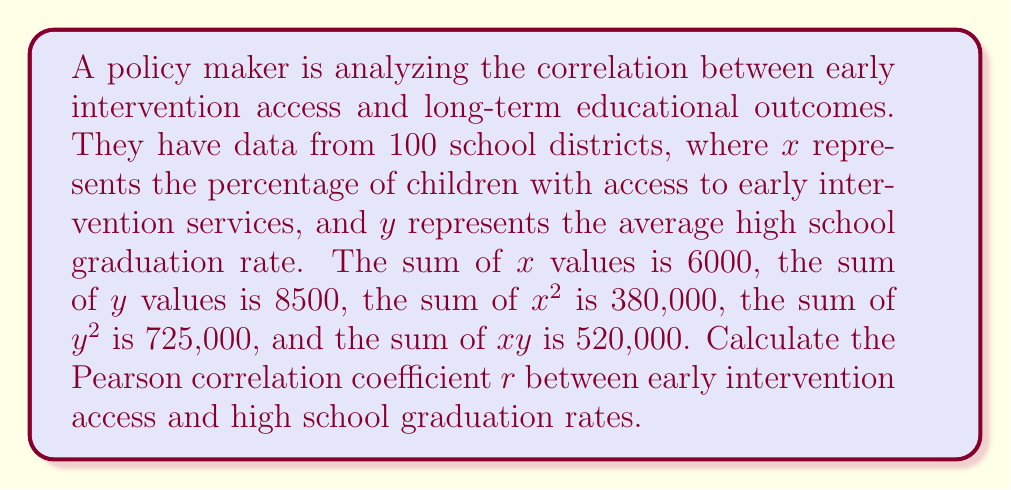What is the answer to this math problem? To calculate the Pearson correlation coefficient, we'll use the formula:

$$r = \frac{n\sum xy - \sum x \sum y}{\sqrt{[n\sum x^2 - (\sum x)^2][n\sum y^2 - (\sum y)^2]}}$$

Where:
$n$ = number of data points (100)
$\sum x$ = sum of x values (6000)
$\sum y$ = sum of y values (8500)
$\sum x^2$ = sum of squared x values (380,000)
$\sum y^2$ = sum of squared y values (725,000)
$\sum xy$ = sum of products of x and y (520,000)

Step 1: Calculate the numerator
$$n\sum xy - \sum x \sum y = (100 \times 520,000) - (6000 \times 8500) = 52,000,000 - 51,000,000 = 1,000,000$$

Step 2: Calculate the first part of the denominator
$$n\sum x^2 - (\sum x)^2 = (100 \times 380,000) - 6000^2 = 38,000,000 - 36,000,000 = 2,000,000$$

Step 3: Calculate the second part of the denominator
$$n\sum y^2 - (\sum y)^2 = (100 \times 725,000) - 8500^2 = 72,500,000 - 72,250,000 = 250,000$$

Step 4: Multiply the results from steps 2 and 3
$$2,000,000 \times 250,000 = 500,000,000,000$$

Step 5: Take the square root of the result from step 4
$$\sqrt{500,000,000,000} = 707,106.7812$$

Step 6: Divide the numerator by the denominator
$$r = \frac{1,000,000}{707,106.7812} \approx 0.1414$$
Answer: $r \approx 0.1414$ 